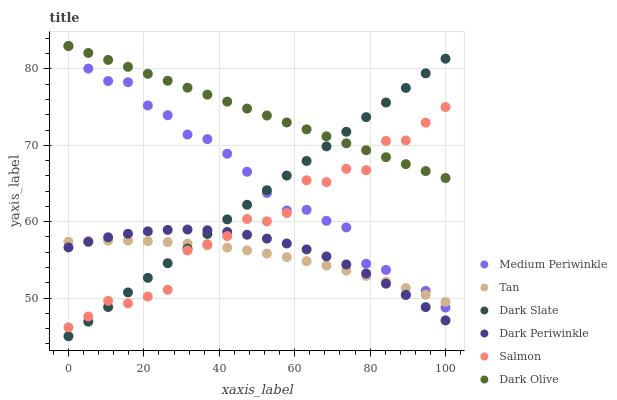Does Tan have the minimum area under the curve?
Answer yes or no. Yes. Does Dark Olive have the maximum area under the curve?
Answer yes or no. Yes. Does Medium Periwinkle have the minimum area under the curve?
Answer yes or no. No. Does Medium Periwinkle have the maximum area under the curve?
Answer yes or no. No. Is Dark Slate the smoothest?
Answer yes or no. Yes. Is Salmon the roughest?
Answer yes or no. Yes. Is Dark Olive the smoothest?
Answer yes or no. No. Is Dark Olive the roughest?
Answer yes or no. No. Does Dark Slate have the lowest value?
Answer yes or no. Yes. Does Medium Periwinkle have the lowest value?
Answer yes or no. No. Does Medium Periwinkle have the highest value?
Answer yes or no. Yes. Does Dark Slate have the highest value?
Answer yes or no. No. Is Dark Periwinkle less than Medium Periwinkle?
Answer yes or no. Yes. Is Medium Periwinkle greater than Dark Periwinkle?
Answer yes or no. Yes. Does Tan intersect Salmon?
Answer yes or no. Yes. Is Tan less than Salmon?
Answer yes or no. No. Is Tan greater than Salmon?
Answer yes or no. No. Does Dark Periwinkle intersect Medium Periwinkle?
Answer yes or no. No. 